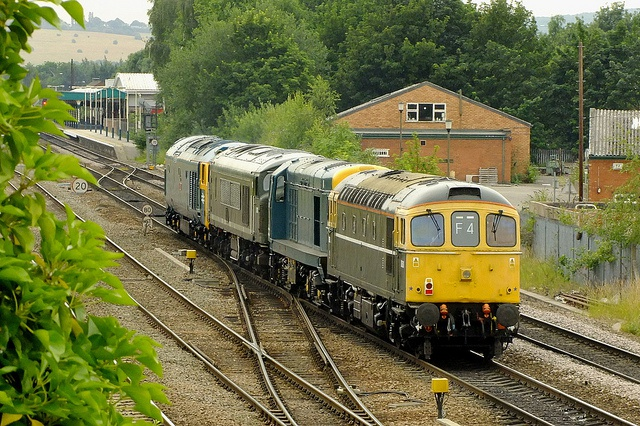Describe the objects in this image and their specific colors. I can see a train in olive, black, gray, orange, and darkgray tones in this image. 